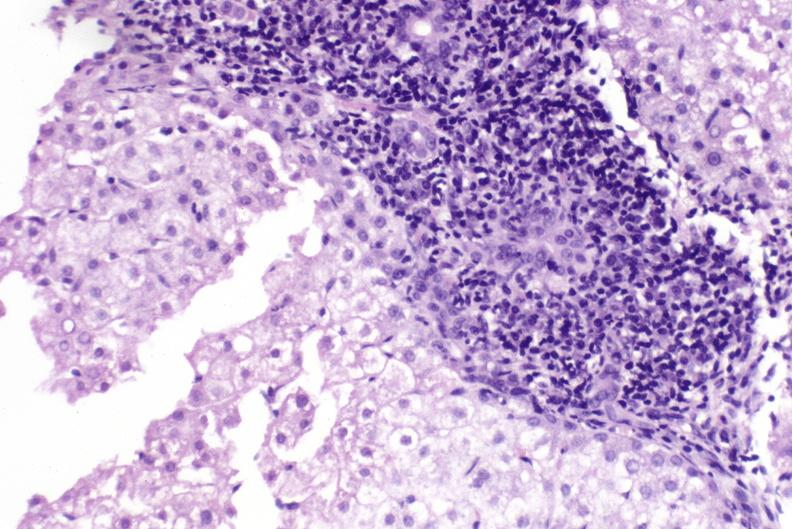what is present?
Answer the question using a single word or phrase. Hepatobiliary 